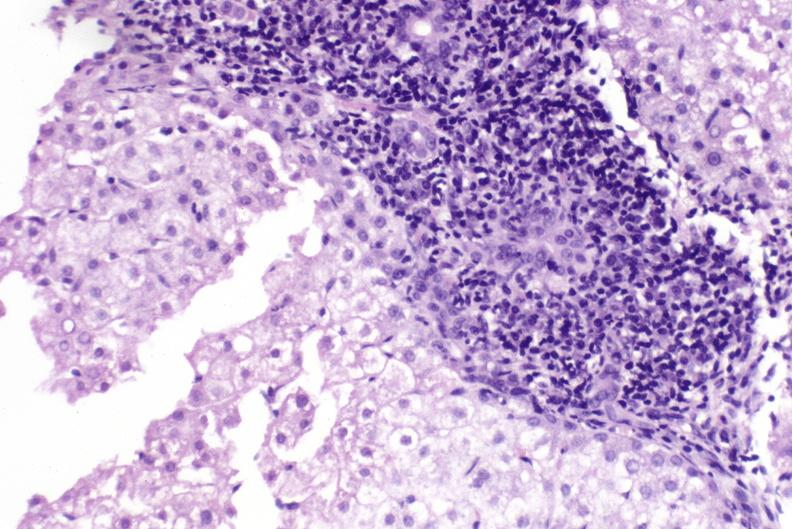what is present?
Answer the question using a single word or phrase. Hepatobiliary 